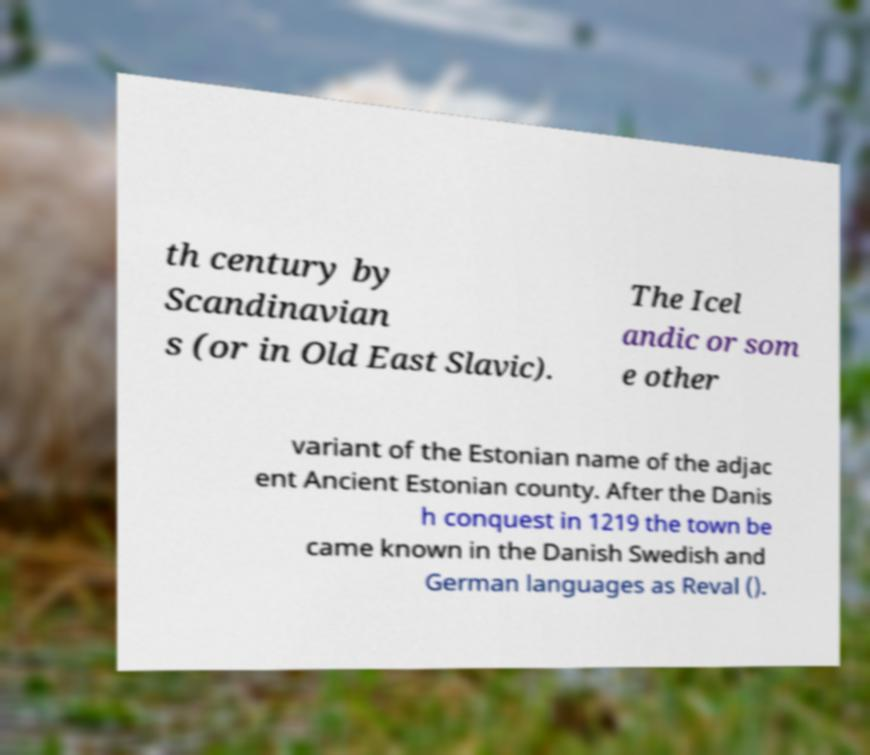Please read and relay the text visible in this image. What does it say? th century by Scandinavian s (or in Old East Slavic). The Icel andic or som e other variant of the Estonian name of the adjac ent Ancient Estonian county. After the Danis h conquest in 1219 the town be came known in the Danish Swedish and German languages as Reval (). 